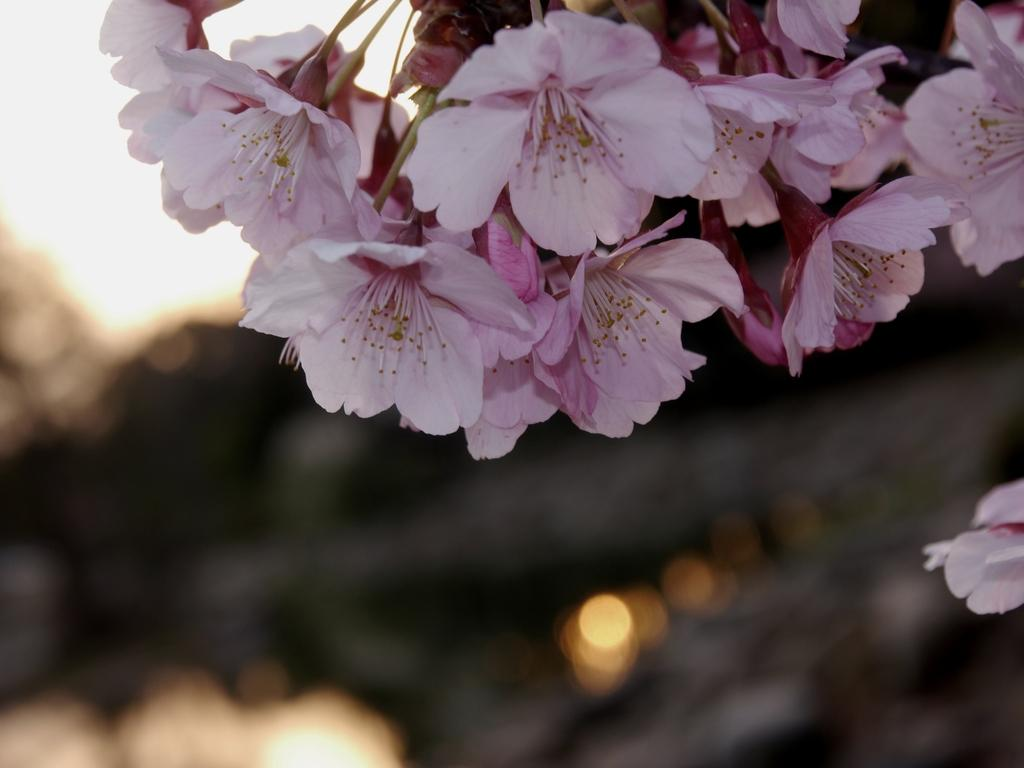What is the main subject of the image? There is a group of flowers in the image. Where are the flowers located in the image? The flowers are at the top of the image. Can you describe the background of the image? The background of the image is blurry. How many ants are carrying the flowers in the image? There are no ants present in the image, and therefore no ants are carrying the flowers. 